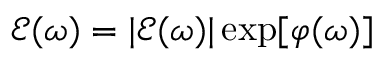<formula> <loc_0><loc_0><loc_500><loc_500>\mathcal { E } ( \omega ) = | \mathcal { E } ( \omega ) | \exp [ \varphi ( \omega ) ]</formula> 